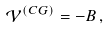Convert formula to latex. <formula><loc_0><loc_0><loc_500><loc_500>\mathcal { V } ^ { ( C G ) } = - B \, ,</formula> 